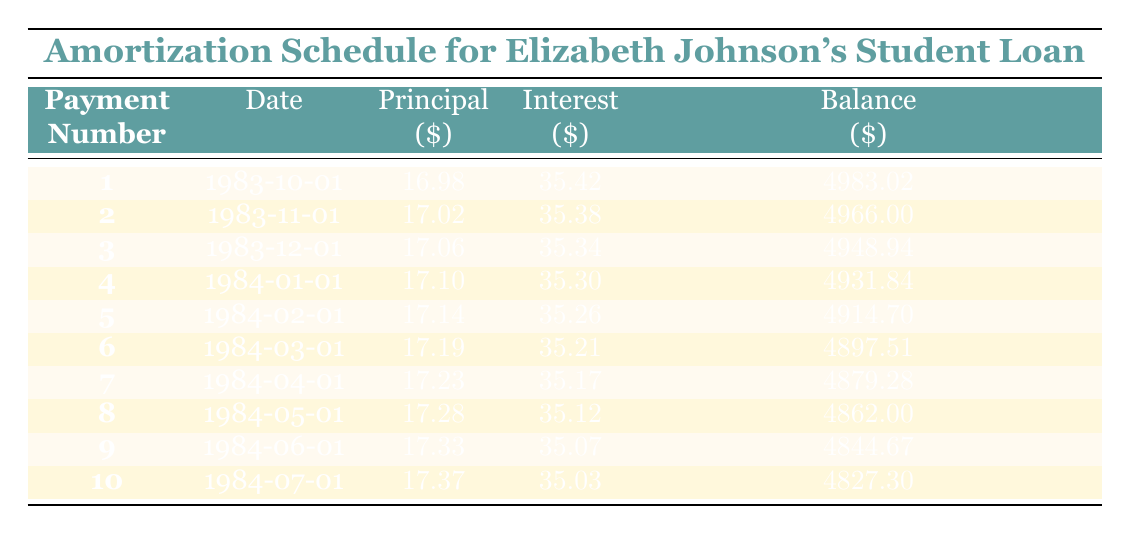What is the loan amount borrowed by Elizabeth Johnson? The table specifies the loan amount at the beginning, showing that Elizabeth Johnson borrowed a total of five thousand dollars.
Answer: 5000 How much was the monthly payment for Elizabeth's student loan? The monthly payment is listed directly in the table as 61.98 dollars.
Answer: 61.98 What was the principal payment in the first month? By reviewing the first row of the table, we can see that the principal payment in the first month was 16.98 dollars.
Answer: 16.98 What is the total interest paid in the first three months combined? To find the total interest paid in the first three months, we add the interest payments: 35.42 (first month) + 35.38 (second month) + 35.34 (third month) = 106.14.
Answer: 106.14 True or False: The remaining balance after the first payment was less than 5000 dollars. In the first row, it lists the remaining balance after the first payment as 4983.02, which is indeed less than 5000.
Answer: True What was the total principal paid by the end of the first five payments? We sum the principal payments from the first five entries: 16.98 + 17.02 + 17.06 + 17.10 + 17.14 = 85.30 dollars.
Answer: 85.30 In which month was the principal payment greater than the interest payment? By examining the entries, from the data of the first ten payments, the principal payment is always less than the interest payment for each month; hence, there are no months where the principal payment is greater.
Answer: None How much did Elizabeth pay in interest over the first ten payments? To find the total interest over the first ten payments, we sum the interest amounts: 35.42 + 35.38 + 35.34 + 35.30 + 35.26 + 35.21 + 35.17 + 35.12 + 35.07 + 35.03 = 352.18 dollars.
Answer: 352.18 What was the remaining loan balance after the fifth payment? This information can be found in the fifth row of the table, which states that the remaining balance after the fifth payment was 4914.70 dollars.
Answer: 4914.70 